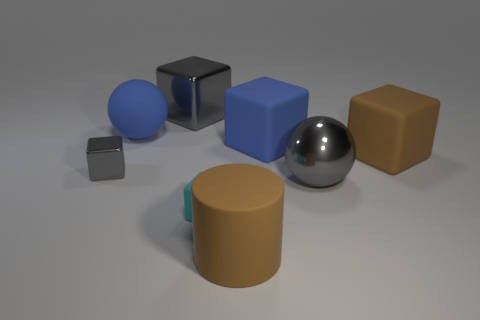What is the large gray block made of?
Make the answer very short. Metal. The cyan matte thing that is the same shape as the tiny gray object is what size?
Your answer should be very brief. Small. There is a brown object that is to the left of the brown matte cube; is it the same size as the tiny gray block?
Make the answer very short. No. What is the size of the cyan matte object?
Your answer should be very brief. Small. What shape is the cyan rubber object?
Give a very brief answer. Cube. Is the number of shiny blocks in front of the blue rubber cube less than the number of large gray metal cubes?
Your response must be concise. No. There is a object that is on the left side of the big blue rubber sphere; does it have the same color as the metal ball?
Ensure brevity in your answer.  Yes. What number of shiny objects are large gray balls or tiny things?
Keep it short and to the point. 2. There is another big block that is made of the same material as the blue cube; what color is it?
Offer a very short reply. Brown. What number of cylinders are cyan rubber things or metal things?
Provide a succinct answer. 0. 